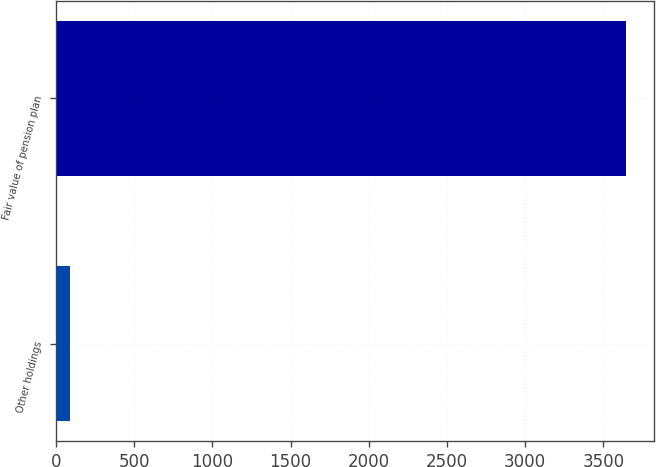<chart> <loc_0><loc_0><loc_500><loc_500><bar_chart><fcel>Other holdings<fcel>Fair value of pension plan<nl><fcel>91<fcel>3642<nl></chart> 